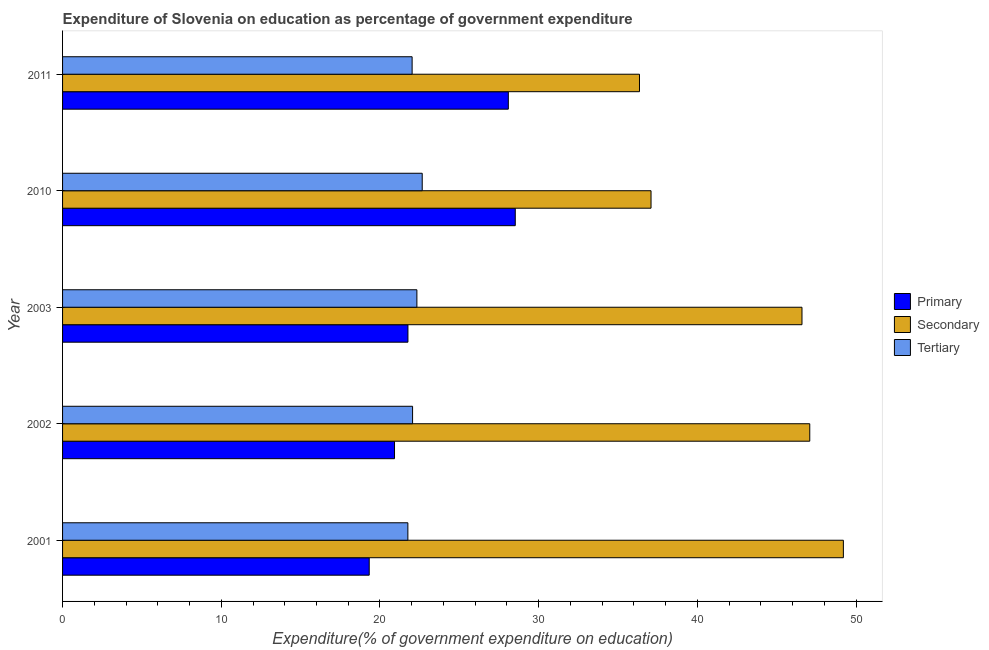How many groups of bars are there?
Ensure brevity in your answer.  5. What is the label of the 2nd group of bars from the top?
Offer a very short reply. 2010. What is the expenditure on primary education in 2002?
Make the answer very short. 20.92. Across all years, what is the maximum expenditure on secondary education?
Ensure brevity in your answer.  49.2. Across all years, what is the minimum expenditure on tertiary education?
Provide a succinct answer. 21.76. In which year was the expenditure on primary education minimum?
Ensure brevity in your answer.  2001. What is the total expenditure on primary education in the graph?
Your answer should be compact. 118.62. What is the difference between the expenditure on tertiary education in 2001 and that in 2003?
Provide a short and direct response. -0.57. What is the difference between the expenditure on primary education in 2011 and the expenditure on secondary education in 2010?
Your answer should be compact. -8.99. What is the average expenditure on tertiary education per year?
Give a very brief answer. 22.17. In the year 2002, what is the difference between the expenditure on primary education and expenditure on secondary education?
Your answer should be very brief. -26.17. In how many years, is the expenditure on tertiary education greater than 40 %?
Your answer should be compact. 0. Is the expenditure on tertiary education in 2001 less than that in 2002?
Make the answer very short. Yes. Is the difference between the expenditure on tertiary education in 2003 and 2010 greater than the difference between the expenditure on primary education in 2003 and 2010?
Keep it short and to the point. Yes. What is the difference between the highest and the second highest expenditure on secondary education?
Your answer should be very brief. 2.12. In how many years, is the expenditure on secondary education greater than the average expenditure on secondary education taken over all years?
Give a very brief answer. 3. What does the 3rd bar from the top in 2003 represents?
Give a very brief answer. Primary. What does the 1st bar from the bottom in 2011 represents?
Offer a very short reply. Primary. How many bars are there?
Keep it short and to the point. 15. Are all the bars in the graph horizontal?
Keep it short and to the point. Yes. How many years are there in the graph?
Your answer should be compact. 5. Are the values on the major ticks of X-axis written in scientific E-notation?
Your answer should be very brief. No. How are the legend labels stacked?
Ensure brevity in your answer.  Vertical. What is the title of the graph?
Your response must be concise. Expenditure of Slovenia on education as percentage of government expenditure. Does "Profit Tax" appear as one of the legend labels in the graph?
Make the answer very short. No. What is the label or title of the X-axis?
Your answer should be compact. Expenditure(% of government expenditure on education). What is the label or title of the Y-axis?
Provide a short and direct response. Year. What is the Expenditure(% of government expenditure on education) of Primary in 2001?
Ensure brevity in your answer.  19.32. What is the Expenditure(% of government expenditure on education) of Secondary in 2001?
Offer a very short reply. 49.2. What is the Expenditure(% of government expenditure on education) of Tertiary in 2001?
Keep it short and to the point. 21.76. What is the Expenditure(% of government expenditure on education) of Primary in 2002?
Offer a very short reply. 20.92. What is the Expenditure(% of government expenditure on education) in Secondary in 2002?
Offer a terse response. 47.08. What is the Expenditure(% of government expenditure on education) in Tertiary in 2002?
Offer a very short reply. 22.06. What is the Expenditure(% of government expenditure on education) in Primary in 2003?
Provide a succinct answer. 21.76. What is the Expenditure(% of government expenditure on education) in Secondary in 2003?
Offer a terse response. 46.59. What is the Expenditure(% of government expenditure on education) in Tertiary in 2003?
Your response must be concise. 22.33. What is the Expenditure(% of government expenditure on education) in Primary in 2010?
Your answer should be very brief. 28.53. What is the Expenditure(% of government expenditure on education) in Secondary in 2010?
Your answer should be compact. 37.08. What is the Expenditure(% of government expenditure on education) in Tertiary in 2010?
Keep it short and to the point. 22.66. What is the Expenditure(% of government expenditure on education) in Primary in 2011?
Make the answer very short. 28.09. What is the Expenditure(% of government expenditure on education) in Secondary in 2011?
Keep it short and to the point. 36.35. What is the Expenditure(% of government expenditure on education) of Tertiary in 2011?
Your response must be concise. 22.03. Across all years, what is the maximum Expenditure(% of government expenditure on education) of Primary?
Provide a short and direct response. 28.53. Across all years, what is the maximum Expenditure(% of government expenditure on education) of Secondary?
Provide a succinct answer. 49.2. Across all years, what is the maximum Expenditure(% of government expenditure on education) in Tertiary?
Make the answer very short. 22.66. Across all years, what is the minimum Expenditure(% of government expenditure on education) in Primary?
Your answer should be compact. 19.32. Across all years, what is the minimum Expenditure(% of government expenditure on education) of Secondary?
Your answer should be very brief. 36.35. Across all years, what is the minimum Expenditure(% of government expenditure on education) of Tertiary?
Provide a short and direct response. 21.76. What is the total Expenditure(% of government expenditure on education) of Primary in the graph?
Keep it short and to the point. 118.62. What is the total Expenditure(% of government expenditure on education) of Secondary in the graph?
Offer a very short reply. 216.32. What is the total Expenditure(% of government expenditure on education) of Tertiary in the graph?
Provide a short and direct response. 110.83. What is the difference between the Expenditure(% of government expenditure on education) of Primary in 2001 and that in 2002?
Offer a terse response. -1.59. What is the difference between the Expenditure(% of government expenditure on education) of Secondary in 2001 and that in 2002?
Offer a terse response. 2.12. What is the difference between the Expenditure(% of government expenditure on education) in Tertiary in 2001 and that in 2002?
Your response must be concise. -0.3. What is the difference between the Expenditure(% of government expenditure on education) of Primary in 2001 and that in 2003?
Give a very brief answer. -2.44. What is the difference between the Expenditure(% of government expenditure on education) in Secondary in 2001 and that in 2003?
Your answer should be compact. 2.61. What is the difference between the Expenditure(% of government expenditure on education) in Tertiary in 2001 and that in 2003?
Ensure brevity in your answer.  -0.57. What is the difference between the Expenditure(% of government expenditure on education) of Primary in 2001 and that in 2010?
Your answer should be compact. -9.2. What is the difference between the Expenditure(% of government expenditure on education) in Secondary in 2001 and that in 2010?
Make the answer very short. 12.12. What is the difference between the Expenditure(% of government expenditure on education) in Tertiary in 2001 and that in 2010?
Make the answer very short. -0.9. What is the difference between the Expenditure(% of government expenditure on education) of Primary in 2001 and that in 2011?
Your answer should be compact. -8.77. What is the difference between the Expenditure(% of government expenditure on education) in Secondary in 2001 and that in 2011?
Offer a terse response. 12.85. What is the difference between the Expenditure(% of government expenditure on education) of Tertiary in 2001 and that in 2011?
Offer a terse response. -0.27. What is the difference between the Expenditure(% of government expenditure on education) in Primary in 2002 and that in 2003?
Give a very brief answer. -0.85. What is the difference between the Expenditure(% of government expenditure on education) in Secondary in 2002 and that in 2003?
Ensure brevity in your answer.  0.49. What is the difference between the Expenditure(% of government expenditure on education) of Tertiary in 2002 and that in 2003?
Your answer should be compact. -0.27. What is the difference between the Expenditure(% of government expenditure on education) in Primary in 2002 and that in 2010?
Your answer should be compact. -7.61. What is the difference between the Expenditure(% of government expenditure on education) in Secondary in 2002 and that in 2010?
Provide a short and direct response. 10. What is the difference between the Expenditure(% of government expenditure on education) of Tertiary in 2002 and that in 2010?
Make the answer very short. -0.61. What is the difference between the Expenditure(% of government expenditure on education) of Primary in 2002 and that in 2011?
Your answer should be compact. -7.17. What is the difference between the Expenditure(% of government expenditure on education) in Secondary in 2002 and that in 2011?
Make the answer very short. 10.73. What is the difference between the Expenditure(% of government expenditure on education) in Tertiary in 2002 and that in 2011?
Provide a succinct answer. 0.03. What is the difference between the Expenditure(% of government expenditure on education) of Primary in 2003 and that in 2010?
Ensure brevity in your answer.  -6.76. What is the difference between the Expenditure(% of government expenditure on education) in Secondary in 2003 and that in 2010?
Offer a very short reply. 9.51. What is the difference between the Expenditure(% of government expenditure on education) of Tertiary in 2003 and that in 2010?
Your answer should be very brief. -0.34. What is the difference between the Expenditure(% of government expenditure on education) of Primary in 2003 and that in 2011?
Offer a very short reply. -6.33. What is the difference between the Expenditure(% of government expenditure on education) of Secondary in 2003 and that in 2011?
Your answer should be compact. 10.24. What is the difference between the Expenditure(% of government expenditure on education) of Tertiary in 2003 and that in 2011?
Your response must be concise. 0.3. What is the difference between the Expenditure(% of government expenditure on education) of Primary in 2010 and that in 2011?
Keep it short and to the point. 0.44. What is the difference between the Expenditure(% of government expenditure on education) in Secondary in 2010 and that in 2011?
Your answer should be very brief. 0.73. What is the difference between the Expenditure(% of government expenditure on education) of Tertiary in 2010 and that in 2011?
Provide a succinct answer. 0.64. What is the difference between the Expenditure(% of government expenditure on education) in Primary in 2001 and the Expenditure(% of government expenditure on education) in Secondary in 2002?
Ensure brevity in your answer.  -27.76. What is the difference between the Expenditure(% of government expenditure on education) in Primary in 2001 and the Expenditure(% of government expenditure on education) in Tertiary in 2002?
Offer a very short reply. -2.73. What is the difference between the Expenditure(% of government expenditure on education) in Secondary in 2001 and the Expenditure(% of government expenditure on education) in Tertiary in 2002?
Make the answer very short. 27.15. What is the difference between the Expenditure(% of government expenditure on education) in Primary in 2001 and the Expenditure(% of government expenditure on education) in Secondary in 2003?
Provide a succinct answer. -27.27. What is the difference between the Expenditure(% of government expenditure on education) of Primary in 2001 and the Expenditure(% of government expenditure on education) of Tertiary in 2003?
Your answer should be compact. -3. What is the difference between the Expenditure(% of government expenditure on education) in Secondary in 2001 and the Expenditure(% of government expenditure on education) in Tertiary in 2003?
Offer a terse response. 26.87. What is the difference between the Expenditure(% of government expenditure on education) in Primary in 2001 and the Expenditure(% of government expenditure on education) in Secondary in 2010?
Offer a terse response. -17.76. What is the difference between the Expenditure(% of government expenditure on education) in Primary in 2001 and the Expenditure(% of government expenditure on education) in Tertiary in 2010?
Offer a very short reply. -3.34. What is the difference between the Expenditure(% of government expenditure on education) of Secondary in 2001 and the Expenditure(% of government expenditure on education) of Tertiary in 2010?
Provide a succinct answer. 26.54. What is the difference between the Expenditure(% of government expenditure on education) of Primary in 2001 and the Expenditure(% of government expenditure on education) of Secondary in 2011?
Offer a terse response. -17.03. What is the difference between the Expenditure(% of government expenditure on education) of Primary in 2001 and the Expenditure(% of government expenditure on education) of Tertiary in 2011?
Your response must be concise. -2.7. What is the difference between the Expenditure(% of government expenditure on education) of Secondary in 2001 and the Expenditure(% of government expenditure on education) of Tertiary in 2011?
Give a very brief answer. 27.18. What is the difference between the Expenditure(% of government expenditure on education) of Primary in 2002 and the Expenditure(% of government expenditure on education) of Secondary in 2003?
Your answer should be compact. -25.68. What is the difference between the Expenditure(% of government expenditure on education) in Primary in 2002 and the Expenditure(% of government expenditure on education) in Tertiary in 2003?
Give a very brief answer. -1.41. What is the difference between the Expenditure(% of government expenditure on education) in Secondary in 2002 and the Expenditure(% of government expenditure on education) in Tertiary in 2003?
Offer a terse response. 24.76. What is the difference between the Expenditure(% of government expenditure on education) of Primary in 2002 and the Expenditure(% of government expenditure on education) of Secondary in 2010?
Give a very brief answer. -16.16. What is the difference between the Expenditure(% of government expenditure on education) of Primary in 2002 and the Expenditure(% of government expenditure on education) of Tertiary in 2010?
Offer a terse response. -1.75. What is the difference between the Expenditure(% of government expenditure on education) of Secondary in 2002 and the Expenditure(% of government expenditure on education) of Tertiary in 2010?
Keep it short and to the point. 24.42. What is the difference between the Expenditure(% of government expenditure on education) in Primary in 2002 and the Expenditure(% of government expenditure on education) in Secondary in 2011?
Your response must be concise. -15.44. What is the difference between the Expenditure(% of government expenditure on education) of Primary in 2002 and the Expenditure(% of government expenditure on education) of Tertiary in 2011?
Your answer should be compact. -1.11. What is the difference between the Expenditure(% of government expenditure on education) in Secondary in 2002 and the Expenditure(% of government expenditure on education) in Tertiary in 2011?
Offer a terse response. 25.06. What is the difference between the Expenditure(% of government expenditure on education) in Primary in 2003 and the Expenditure(% of government expenditure on education) in Secondary in 2010?
Offer a very short reply. -15.32. What is the difference between the Expenditure(% of government expenditure on education) in Primary in 2003 and the Expenditure(% of government expenditure on education) in Tertiary in 2010?
Provide a succinct answer. -0.9. What is the difference between the Expenditure(% of government expenditure on education) in Secondary in 2003 and the Expenditure(% of government expenditure on education) in Tertiary in 2010?
Provide a short and direct response. 23.93. What is the difference between the Expenditure(% of government expenditure on education) in Primary in 2003 and the Expenditure(% of government expenditure on education) in Secondary in 2011?
Offer a very short reply. -14.59. What is the difference between the Expenditure(% of government expenditure on education) in Primary in 2003 and the Expenditure(% of government expenditure on education) in Tertiary in 2011?
Make the answer very short. -0.26. What is the difference between the Expenditure(% of government expenditure on education) of Secondary in 2003 and the Expenditure(% of government expenditure on education) of Tertiary in 2011?
Make the answer very short. 24.57. What is the difference between the Expenditure(% of government expenditure on education) in Primary in 2010 and the Expenditure(% of government expenditure on education) in Secondary in 2011?
Offer a terse response. -7.83. What is the difference between the Expenditure(% of government expenditure on education) in Primary in 2010 and the Expenditure(% of government expenditure on education) in Tertiary in 2011?
Offer a terse response. 6.5. What is the difference between the Expenditure(% of government expenditure on education) in Secondary in 2010 and the Expenditure(% of government expenditure on education) in Tertiary in 2011?
Keep it short and to the point. 15.06. What is the average Expenditure(% of government expenditure on education) of Primary per year?
Your answer should be very brief. 23.72. What is the average Expenditure(% of government expenditure on education) of Secondary per year?
Ensure brevity in your answer.  43.26. What is the average Expenditure(% of government expenditure on education) in Tertiary per year?
Offer a very short reply. 22.17. In the year 2001, what is the difference between the Expenditure(% of government expenditure on education) of Primary and Expenditure(% of government expenditure on education) of Secondary?
Your response must be concise. -29.88. In the year 2001, what is the difference between the Expenditure(% of government expenditure on education) of Primary and Expenditure(% of government expenditure on education) of Tertiary?
Give a very brief answer. -2.44. In the year 2001, what is the difference between the Expenditure(% of government expenditure on education) of Secondary and Expenditure(% of government expenditure on education) of Tertiary?
Provide a short and direct response. 27.44. In the year 2002, what is the difference between the Expenditure(% of government expenditure on education) of Primary and Expenditure(% of government expenditure on education) of Secondary?
Provide a short and direct response. -26.17. In the year 2002, what is the difference between the Expenditure(% of government expenditure on education) in Primary and Expenditure(% of government expenditure on education) in Tertiary?
Provide a succinct answer. -1.14. In the year 2002, what is the difference between the Expenditure(% of government expenditure on education) of Secondary and Expenditure(% of government expenditure on education) of Tertiary?
Your answer should be compact. 25.03. In the year 2003, what is the difference between the Expenditure(% of government expenditure on education) of Primary and Expenditure(% of government expenditure on education) of Secondary?
Give a very brief answer. -24.83. In the year 2003, what is the difference between the Expenditure(% of government expenditure on education) of Primary and Expenditure(% of government expenditure on education) of Tertiary?
Give a very brief answer. -0.56. In the year 2003, what is the difference between the Expenditure(% of government expenditure on education) in Secondary and Expenditure(% of government expenditure on education) in Tertiary?
Give a very brief answer. 24.27. In the year 2010, what is the difference between the Expenditure(% of government expenditure on education) in Primary and Expenditure(% of government expenditure on education) in Secondary?
Offer a terse response. -8.56. In the year 2010, what is the difference between the Expenditure(% of government expenditure on education) in Primary and Expenditure(% of government expenditure on education) in Tertiary?
Provide a short and direct response. 5.86. In the year 2010, what is the difference between the Expenditure(% of government expenditure on education) in Secondary and Expenditure(% of government expenditure on education) in Tertiary?
Provide a succinct answer. 14.42. In the year 2011, what is the difference between the Expenditure(% of government expenditure on education) in Primary and Expenditure(% of government expenditure on education) in Secondary?
Your response must be concise. -8.26. In the year 2011, what is the difference between the Expenditure(% of government expenditure on education) in Primary and Expenditure(% of government expenditure on education) in Tertiary?
Offer a terse response. 6.06. In the year 2011, what is the difference between the Expenditure(% of government expenditure on education) of Secondary and Expenditure(% of government expenditure on education) of Tertiary?
Provide a short and direct response. 14.33. What is the ratio of the Expenditure(% of government expenditure on education) of Primary in 2001 to that in 2002?
Your answer should be compact. 0.92. What is the ratio of the Expenditure(% of government expenditure on education) in Secondary in 2001 to that in 2002?
Ensure brevity in your answer.  1.04. What is the ratio of the Expenditure(% of government expenditure on education) in Tertiary in 2001 to that in 2002?
Your response must be concise. 0.99. What is the ratio of the Expenditure(% of government expenditure on education) of Primary in 2001 to that in 2003?
Keep it short and to the point. 0.89. What is the ratio of the Expenditure(% of government expenditure on education) of Secondary in 2001 to that in 2003?
Your answer should be very brief. 1.06. What is the ratio of the Expenditure(% of government expenditure on education) of Tertiary in 2001 to that in 2003?
Keep it short and to the point. 0.97. What is the ratio of the Expenditure(% of government expenditure on education) of Primary in 2001 to that in 2010?
Offer a very short reply. 0.68. What is the ratio of the Expenditure(% of government expenditure on education) of Secondary in 2001 to that in 2010?
Your answer should be very brief. 1.33. What is the ratio of the Expenditure(% of government expenditure on education) of Tertiary in 2001 to that in 2010?
Ensure brevity in your answer.  0.96. What is the ratio of the Expenditure(% of government expenditure on education) of Primary in 2001 to that in 2011?
Provide a succinct answer. 0.69. What is the ratio of the Expenditure(% of government expenditure on education) of Secondary in 2001 to that in 2011?
Ensure brevity in your answer.  1.35. What is the ratio of the Expenditure(% of government expenditure on education) in Tertiary in 2001 to that in 2011?
Give a very brief answer. 0.99. What is the ratio of the Expenditure(% of government expenditure on education) in Primary in 2002 to that in 2003?
Give a very brief answer. 0.96. What is the ratio of the Expenditure(% of government expenditure on education) in Secondary in 2002 to that in 2003?
Provide a short and direct response. 1.01. What is the ratio of the Expenditure(% of government expenditure on education) in Tertiary in 2002 to that in 2003?
Give a very brief answer. 0.99. What is the ratio of the Expenditure(% of government expenditure on education) of Primary in 2002 to that in 2010?
Your answer should be very brief. 0.73. What is the ratio of the Expenditure(% of government expenditure on education) in Secondary in 2002 to that in 2010?
Give a very brief answer. 1.27. What is the ratio of the Expenditure(% of government expenditure on education) in Tertiary in 2002 to that in 2010?
Your answer should be compact. 0.97. What is the ratio of the Expenditure(% of government expenditure on education) in Primary in 2002 to that in 2011?
Offer a very short reply. 0.74. What is the ratio of the Expenditure(% of government expenditure on education) in Secondary in 2002 to that in 2011?
Ensure brevity in your answer.  1.3. What is the ratio of the Expenditure(% of government expenditure on education) of Primary in 2003 to that in 2010?
Your answer should be very brief. 0.76. What is the ratio of the Expenditure(% of government expenditure on education) in Secondary in 2003 to that in 2010?
Offer a terse response. 1.26. What is the ratio of the Expenditure(% of government expenditure on education) of Tertiary in 2003 to that in 2010?
Offer a very short reply. 0.99. What is the ratio of the Expenditure(% of government expenditure on education) of Primary in 2003 to that in 2011?
Your answer should be very brief. 0.77. What is the ratio of the Expenditure(% of government expenditure on education) in Secondary in 2003 to that in 2011?
Your response must be concise. 1.28. What is the ratio of the Expenditure(% of government expenditure on education) of Tertiary in 2003 to that in 2011?
Provide a short and direct response. 1.01. What is the ratio of the Expenditure(% of government expenditure on education) in Primary in 2010 to that in 2011?
Ensure brevity in your answer.  1.02. What is the ratio of the Expenditure(% of government expenditure on education) in Secondary in 2010 to that in 2011?
Keep it short and to the point. 1.02. What is the ratio of the Expenditure(% of government expenditure on education) of Tertiary in 2010 to that in 2011?
Provide a succinct answer. 1.03. What is the difference between the highest and the second highest Expenditure(% of government expenditure on education) in Primary?
Your answer should be compact. 0.44. What is the difference between the highest and the second highest Expenditure(% of government expenditure on education) in Secondary?
Your response must be concise. 2.12. What is the difference between the highest and the second highest Expenditure(% of government expenditure on education) of Tertiary?
Your answer should be very brief. 0.34. What is the difference between the highest and the lowest Expenditure(% of government expenditure on education) of Primary?
Offer a very short reply. 9.2. What is the difference between the highest and the lowest Expenditure(% of government expenditure on education) in Secondary?
Ensure brevity in your answer.  12.85. What is the difference between the highest and the lowest Expenditure(% of government expenditure on education) in Tertiary?
Your answer should be compact. 0.9. 